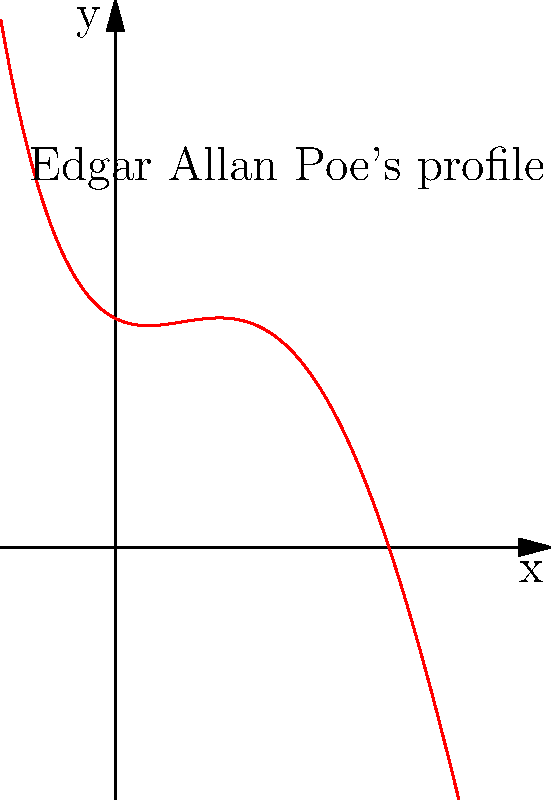In the graph above, the red curve represents a polynomial function that outlines the silhouette of Edgar Allan Poe's face in profile. The function is given by $f(x) = 0.1x^4 - 0.8x^3 + 1.2x^2 - 0.5x + 2$. What is the degree of this polynomial, and how many potential turning points could this curve have? To answer this question, we need to analyze the given polynomial function:

1. Degree of the polynomial:
   The degree of a polynomial is determined by the highest power of x in the function.
   In this case, $f(x) = 0.1x^4 - 0.8x^3 + 1.2x^2 - 0.5x + 2$
   The highest power of x is 4, so the degree of the polynomial is 4.

2. Potential turning points:
   The number of potential turning points is related to the degree of the polynomial.
   For a polynomial of degree n, the maximum number of turning points is (n-1).
   Since our polynomial is of degree 4, the maximum number of turning points is:
   4 - 1 = 3

Therefore, this quartic (4th degree) polynomial could have up to 3 turning points.

This result aligns well with the visual representation of Edgar Allan Poe's profile, which could have turning points at the forehead, nose, and chin areas.
Answer: Degree: 4; Potential turning points: 3 